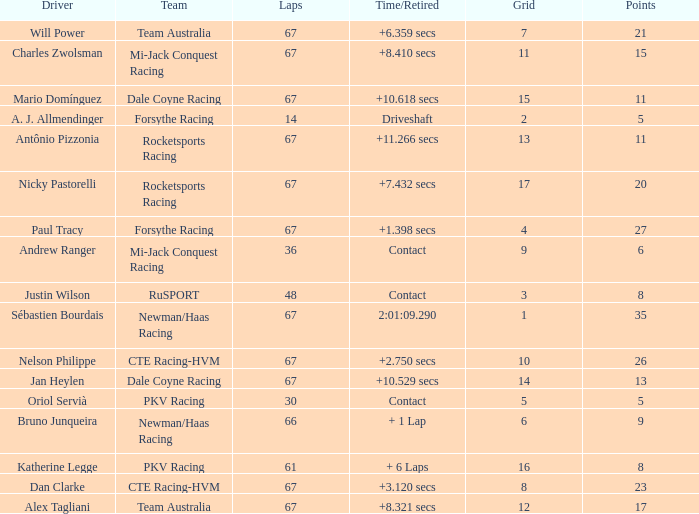How many average laps for Alex Tagliani with more than 17 points? None. 